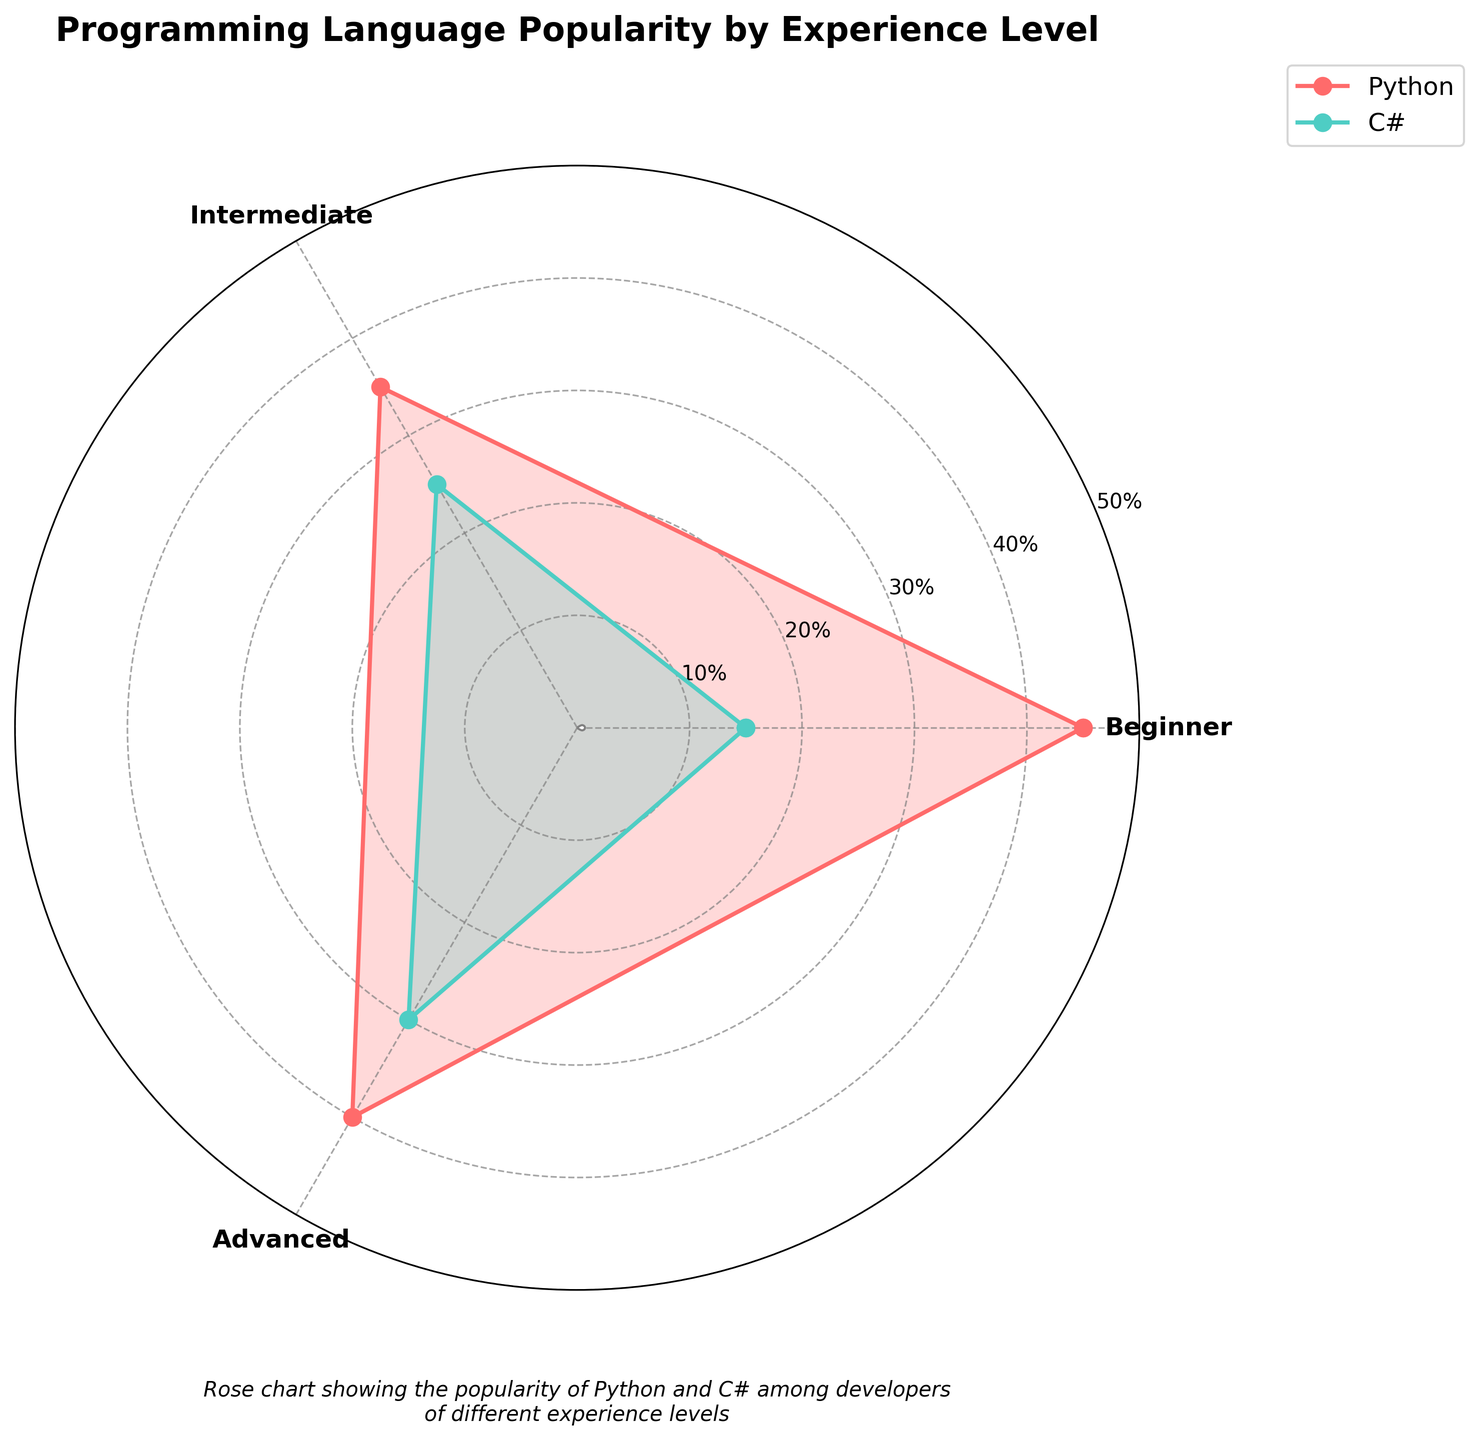What is the title of the figure? The title is usually positioned at the top of the figure and is clearly written in a larger, bold font.
Answer: Programming Language Popularity by Experience Level How many experience levels are shown in the figure? The figure has angular tick labels which correspond to the experience levels. These labels help us count the number of experience levels.
Answer: 3 Which programming language is depicted with red color? The figure legend indicates the color associated with each programming language. By referring to the legend, we can identify the color for each language.
Answer: Python Which experience level has the highest percentage for C#? By observing the radial values and comparing them across the experience levels for the C# color plot, we can identify the highest point.
Answer: Advanced What is the percentage popularity of Python among beginners? By looking at the radial distance from the center at the angle corresponding to the "Beginner" experience level for the Python color, we can read the percentage value.
Answer: 45% Which programming language is more popular among intermediate developers? Comparing the radial distances for both Python and C# at the "Intermediate" experience level, we see which one extends further from the center.
Answer: Python What is the average percentage popularity of Python across all experience levels? The values for Python are 45, 35, and 40. Adding them up (45 + 35 + 40 = 120) and dividing by the number of values (120/3) gives the average.
Answer: 40% Which experience level shows an equal or near-equal popularity between Python and C#? By comparing the radial points for both languages at each experience level, we look for levels where the distances from the center are closest.
Answer: Advanced How does the popularity of Python change as experience level increases? By observing the Python color plot, we see the trend of the radial distances. It decreases from Beginner to Intermediate and then slightly increases at Advanced.
Answer: Decreases then increases What is the combined popularity percentage of C# at the intermediate and advanced experience levels? By summing the percentages for Intermediate and Advanced (25 + 30), we get the combined percentage for these levels.
Answer: 55% 